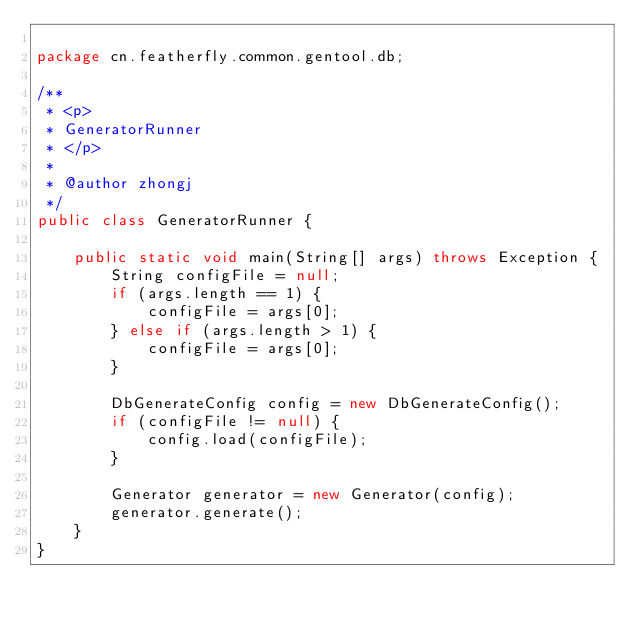Convert code to text. <code><loc_0><loc_0><loc_500><loc_500><_Java_>
package cn.featherfly.common.gentool.db;

/**
 * <p>
 * GeneratorRunner
 * </p>
 *
 * @author zhongj
 */
public class GeneratorRunner {

    public static void main(String[] args) throws Exception {
        String configFile = null;
        if (args.length == 1) {
            configFile = args[0];
        } else if (args.length > 1) {
            configFile = args[0];
        }

        DbGenerateConfig config = new DbGenerateConfig();
        if (configFile != null) {
            config.load(configFile);
        }

        Generator generator = new Generator(config);
        generator.generate();
    }
}
</code> 